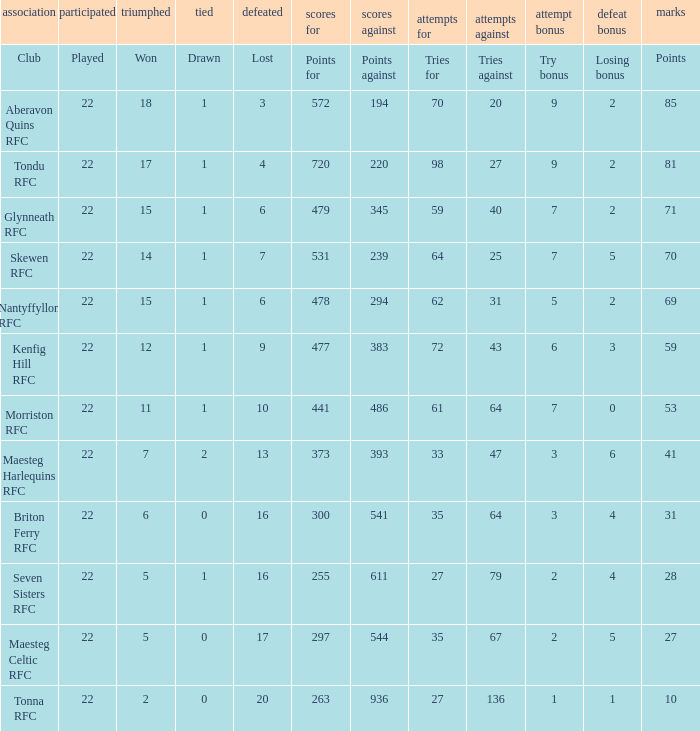What is the value of the points column when the value of the column lost is "lost" Points. Can you parse all the data within this table? {'header': ['association', 'participated', 'triumphed', 'tied', 'defeated', 'scores for', 'scores against', 'attempts for', 'attempts against', 'attempt bonus', 'defeat bonus', 'marks'], 'rows': [['Club', 'Played', 'Won', 'Drawn', 'Lost', 'Points for', 'Points against', 'Tries for', 'Tries against', 'Try bonus', 'Losing bonus', 'Points'], ['Aberavon Quins RFC', '22', '18', '1', '3', '572', '194', '70', '20', '9', '2', '85'], ['Tondu RFC', '22', '17', '1', '4', '720', '220', '98', '27', '9', '2', '81'], ['Glynneath RFC', '22', '15', '1', '6', '479', '345', '59', '40', '7', '2', '71'], ['Skewen RFC', '22', '14', '1', '7', '531', '239', '64', '25', '7', '5', '70'], ['Nantyffyllon RFC', '22', '15', '1', '6', '478', '294', '62', '31', '5', '2', '69'], ['Kenfig Hill RFC', '22', '12', '1', '9', '477', '383', '72', '43', '6', '3', '59'], ['Morriston RFC', '22', '11', '1', '10', '441', '486', '61', '64', '7', '0', '53'], ['Maesteg Harlequins RFC', '22', '7', '2', '13', '373', '393', '33', '47', '3', '6', '41'], ['Briton Ferry RFC', '22', '6', '0', '16', '300', '541', '35', '64', '3', '4', '31'], ['Seven Sisters RFC', '22', '5', '1', '16', '255', '611', '27', '79', '2', '4', '28'], ['Maesteg Celtic RFC', '22', '5', '0', '17', '297', '544', '35', '67', '2', '5', '27'], ['Tonna RFC', '22', '2', '0', '20', '263', '936', '27', '136', '1', '1', '10']]} 